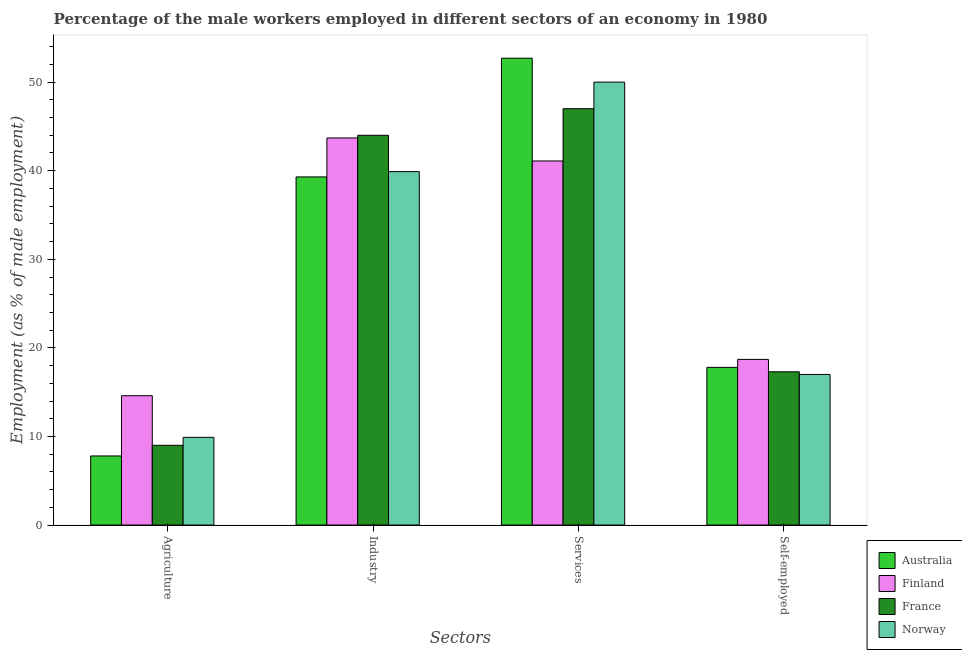How many different coloured bars are there?
Offer a terse response. 4. Are the number of bars per tick equal to the number of legend labels?
Provide a short and direct response. Yes. Are the number of bars on each tick of the X-axis equal?
Keep it short and to the point. Yes. How many bars are there on the 1st tick from the left?
Give a very brief answer. 4. How many bars are there on the 4th tick from the right?
Ensure brevity in your answer.  4. What is the label of the 3rd group of bars from the left?
Your answer should be compact. Services. What is the percentage of male workers in industry in Finland?
Offer a terse response. 43.7. Across all countries, what is the maximum percentage of male workers in industry?
Provide a short and direct response. 44. In which country was the percentage of male workers in agriculture minimum?
Offer a terse response. Australia. What is the total percentage of male workers in agriculture in the graph?
Keep it short and to the point. 41.3. What is the difference between the percentage of male workers in industry in France and that in Norway?
Offer a very short reply. 4.1. What is the difference between the percentage of male workers in industry in Australia and the percentage of self employed male workers in Finland?
Your response must be concise. 20.6. What is the average percentage of male workers in agriculture per country?
Ensure brevity in your answer.  10.33. What is the difference between the percentage of male workers in industry and percentage of male workers in services in France?
Your answer should be compact. -3. What is the ratio of the percentage of self employed male workers in Australia to that in Norway?
Ensure brevity in your answer.  1.05. Is the difference between the percentage of male workers in industry in Finland and Australia greater than the difference between the percentage of male workers in agriculture in Finland and Australia?
Your answer should be compact. No. What is the difference between the highest and the second highest percentage of male workers in industry?
Your answer should be compact. 0.3. What is the difference between the highest and the lowest percentage of male workers in agriculture?
Ensure brevity in your answer.  6.8. In how many countries, is the percentage of male workers in services greater than the average percentage of male workers in services taken over all countries?
Give a very brief answer. 2. Is it the case that in every country, the sum of the percentage of self employed male workers and percentage of male workers in industry is greater than the sum of percentage of male workers in agriculture and percentage of male workers in services?
Keep it short and to the point. Yes. What does the 3rd bar from the left in Self-employed represents?
Provide a short and direct response. France. What does the 2nd bar from the right in Agriculture represents?
Your response must be concise. France. Is it the case that in every country, the sum of the percentage of male workers in agriculture and percentage of male workers in industry is greater than the percentage of male workers in services?
Keep it short and to the point. No. Are all the bars in the graph horizontal?
Keep it short and to the point. No. What is the difference between two consecutive major ticks on the Y-axis?
Your answer should be very brief. 10. Are the values on the major ticks of Y-axis written in scientific E-notation?
Provide a short and direct response. No. Does the graph contain any zero values?
Provide a short and direct response. No. How are the legend labels stacked?
Keep it short and to the point. Vertical. What is the title of the graph?
Offer a very short reply. Percentage of the male workers employed in different sectors of an economy in 1980. Does "Fiji" appear as one of the legend labels in the graph?
Offer a terse response. No. What is the label or title of the X-axis?
Keep it short and to the point. Sectors. What is the label or title of the Y-axis?
Offer a terse response. Employment (as % of male employment). What is the Employment (as % of male employment) of Australia in Agriculture?
Your answer should be very brief. 7.8. What is the Employment (as % of male employment) of Finland in Agriculture?
Make the answer very short. 14.6. What is the Employment (as % of male employment) of France in Agriculture?
Ensure brevity in your answer.  9. What is the Employment (as % of male employment) in Norway in Agriculture?
Offer a very short reply. 9.9. What is the Employment (as % of male employment) in Australia in Industry?
Your answer should be very brief. 39.3. What is the Employment (as % of male employment) in Finland in Industry?
Offer a terse response. 43.7. What is the Employment (as % of male employment) in Norway in Industry?
Offer a terse response. 39.9. What is the Employment (as % of male employment) in Australia in Services?
Keep it short and to the point. 52.7. What is the Employment (as % of male employment) of Finland in Services?
Offer a very short reply. 41.1. What is the Employment (as % of male employment) in Australia in Self-employed?
Provide a succinct answer. 17.8. What is the Employment (as % of male employment) in Finland in Self-employed?
Your answer should be very brief. 18.7. What is the Employment (as % of male employment) in France in Self-employed?
Ensure brevity in your answer.  17.3. What is the Employment (as % of male employment) of Norway in Self-employed?
Make the answer very short. 17. Across all Sectors, what is the maximum Employment (as % of male employment) in Australia?
Provide a succinct answer. 52.7. Across all Sectors, what is the maximum Employment (as % of male employment) in Finland?
Your response must be concise. 43.7. Across all Sectors, what is the minimum Employment (as % of male employment) of Australia?
Offer a very short reply. 7.8. Across all Sectors, what is the minimum Employment (as % of male employment) in Finland?
Your answer should be compact. 14.6. Across all Sectors, what is the minimum Employment (as % of male employment) in Norway?
Ensure brevity in your answer.  9.9. What is the total Employment (as % of male employment) in Australia in the graph?
Your response must be concise. 117.6. What is the total Employment (as % of male employment) of Finland in the graph?
Your response must be concise. 118.1. What is the total Employment (as % of male employment) of France in the graph?
Your response must be concise. 117.3. What is the total Employment (as % of male employment) of Norway in the graph?
Give a very brief answer. 116.8. What is the difference between the Employment (as % of male employment) in Australia in Agriculture and that in Industry?
Your answer should be very brief. -31.5. What is the difference between the Employment (as % of male employment) in Finland in Agriculture and that in Industry?
Offer a very short reply. -29.1. What is the difference between the Employment (as % of male employment) in France in Agriculture and that in Industry?
Provide a succinct answer. -35. What is the difference between the Employment (as % of male employment) in Australia in Agriculture and that in Services?
Give a very brief answer. -44.9. What is the difference between the Employment (as % of male employment) of Finland in Agriculture and that in Services?
Your answer should be compact. -26.5. What is the difference between the Employment (as % of male employment) in France in Agriculture and that in Services?
Your answer should be very brief. -38. What is the difference between the Employment (as % of male employment) of Norway in Agriculture and that in Services?
Offer a terse response. -40.1. What is the difference between the Employment (as % of male employment) in France in Agriculture and that in Self-employed?
Keep it short and to the point. -8.3. What is the difference between the Employment (as % of male employment) of Norway in Agriculture and that in Self-employed?
Your response must be concise. -7.1. What is the difference between the Employment (as % of male employment) of Australia in Industry and that in Services?
Your answer should be very brief. -13.4. What is the difference between the Employment (as % of male employment) of Finland in Industry and that in Services?
Your response must be concise. 2.6. What is the difference between the Employment (as % of male employment) of France in Industry and that in Services?
Ensure brevity in your answer.  -3. What is the difference between the Employment (as % of male employment) of Norway in Industry and that in Services?
Ensure brevity in your answer.  -10.1. What is the difference between the Employment (as % of male employment) in Australia in Industry and that in Self-employed?
Provide a succinct answer. 21.5. What is the difference between the Employment (as % of male employment) in France in Industry and that in Self-employed?
Keep it short and to the point. 26.7. What is the difference between the Employment (as % of male employment) of Norway in Industry and that in Self-employed?
Offer a very short reply. 22.9. What is the difference between the Employment (as % of male employment) of Australia in Services and that in Self-employed?
Give a very brief answer. 34.9. What is the difference between the Employment (as % of male employment) in Finland in Services and that in Self-employed?
Ensure brevity in your answer.  22.4. What is the difference between the Employment (as % of male employment) in France in Services and that in Self-employed?
Provide a short and direct response. 29.7. What is the difference between the Employment (as % of male employment) of Norway in Services and that in Self-employed?
Offer a terse response. 33. What is the difference between the Employment (as % of male employment) in Australia in Agriculture and the Employment (as % of male employment) in Finland in Industry?
Your answer should be very brief. -35.9. What is the difference between the Employment (as % of male employment) in Australia in Agriculture and the Employment (as % of male employment) in France in Industry?
Give a very brief answer. -36.2. What is the difference between the Employment (as % of male employment) in Australia in Agriculture and the Employment (as % of male employment) in Norway in Industry?
Provide a succinct answer. -32.1. What is the difference between the Employment (as % of male employment) in Finland in Agriculture and the Employment (as % of male employment) in France in Industry?
Your answer should be very brief. -29.4. What is the difference between the Employment (as % of male employment) of Finland in Agriculture and the Employment (as % of male employment) of Norway in Industry?
Your response must be concise. -25.3. What is the difference between the Employment (as % of male employment) in France in Agriculture and the Employment (as % of male employment) in Norway in Industry?
Give a very brief answer. -30.9. What is the difference between the Employment (as % of male employment) of Australia in Agriculture and the Employment (as % of male employment) of Finland in Services?
Provide a succinct answer. -33.3. What is the difference between the Employment (as % of male employment) of Australia in Agriculture and the Employment (as % of male employment) of France in Services?
Keep it short and to the point. -39.2. What is the difference between the Employment (as % of male employment) of Australia in Agriculture and the Employment (as % of male employment) of Norway in Services?
Your response must be concise. -42.2. What is the difference between the Employment (as % of male employment) in Finland in Agriculture and the Employment (as % of male employment) in France in Services?
Ensure brevity in your answer.  -32.4. What is the difference between the Employment (as % of male employment) of Finland in Agriculture and the Employment (as % of male employment) of Norway in Services?
Offer a terse response. -35.4. What is the difference between the Employment (as % of male employment) in France in Agriculture and the Employment (as % of male employment) in Norway in Services?
Offer a terse response. -41. What is the difference between the Employment (as % of male employment) in Australia in Agriculture and the Employment (as % of male employment) in France in Self-employed?
Make the answer very short. -9.5. What is the difference between the Employment (as % of male employment) of Australia in Agriculture and the Employment (as % of male employment) of Norway in Self-employed?
Provide a succinct answer. -9.2. What is the difference between the Employment (as % of male employment) of Finland in Agriculture and the Employment (as % of male employment) of France in Self-employed?
Give a very brief answer. -2.7. What is the difference between the Employment (as % of male employment) of Finland in Agriculture and the Employment (as % of male employment) of Norway in Self-employed?
Provide a succinct answer. -2.4. What is the difference between the Employment (as % of male employment) of Finland in Industry and the Employment (as % of male employment) of Norway in Services?
Your answer should be compact. -6.3. What is the difference between the Employment (as % of male employment) of Australia in Industry and the Employment (as % of male employment) of Finland in Self-employed?
Keep it short and to the point. 20.6. What is the difference between the Employment (as % of male employment) of Australia in Industry and the Employment (as % of male employment) of France in Self-employed?
Give a very brief answer. 22. What is the difference between the Employment (as % of male employment) of Australia in Industry and the Employment (as % of male employment) of Norway in Self-employed?
Offer a terse response. 22.3. What is the difference between the Employment (as % of male employment) in Finland in Industry and the Employment (as % of male employment) in France in Self-employed?
Offer a terse response. 26.4. What is the difference between the Employment (as % of male employment) in Finland in Industry and the Employment (as % of male employment) in Norway in Self-employed?
Your answer should be very brief. 26.7. What is the difference between the Employment (as % of male employment) of France in Industry and the Employment (as % of male employment) of Norway in Self-employed?
Provide a succinct answer. 27. What is the difference between the Employment (as % of male employment) in Australia in Services and the Employment (as % of male employment) in France in Self-employed?
Offer a very short reply. 35.4. What is the difference between the Employment (as % of male employment) in Australia in Services and the Employment (as % of male employment) in Norway in Self-employed?
Your response must be concise. 35.7. What is the difference between the Employment (as % of male employment) in Finland in Services and the Employment (as % of male employment) in France in Self-employed?
Offer a very short reply. 23.8. What is the difference between the Employment (as % of male employment) of Finland in Services and the Employment (as % of male employment) of Norway in Self-employed?
Offer a very short reply. 24.1. What is the difference between the Employment (as % of male employment) in France in Services and the Employment (as % of male employment) in Norway in Self-employed?
Your answer should be very brief. 30. What is the average Employment (as % of male employment) of Australia per Sectors?
Your answer should be compact. 29.4. What is the average Employment (as % of male employment) in Finland per Sectors?
Your answer should be compact. 29.52. What is the average Employment (as % of male employment) in France per Sectors?
Your response must be concise. 29.32. What is the average Employment (as % of male employment) in Norway per Sectors?
Keep it short and to the point. 29.2. What is the difference between the Employment (as % of male employment) of Finland and Employment (as % of male employment) of France in Agriculture?
Offer a terse response. 5.6. What is the difference between the Employment (as % of male employment) of Australia and Employment (as % of male employment) of Finland in Industry?
Provide a succinct answer. -4.4. What is the difference between the Employment (as % of male employment) in Australia and Employment (as % of male employment) in Norway in Industry?
Your response must be concise. -0.6. What is the difference between the Employment (as % of male employment) in Finland and Employment (as % of male employment) in Norway in Industry?
Make the answer very short. 3.8. What is the difference between the Employment (as % of male employment) of France and Employment (as % of male employment) of Norway in Industry?
Offer a terse response. 4.1. What is the difference between the Employment (as % of male employment) in Australia and Employment (as % of male employment) in Finland in Services?
Keep it short and to the point. 11.6. What is the difference between the Employment (as % of male employment) of Australia and Employment (as % of male employment) of France in Services?
Offer a very short reply. 5.7. What is the difference between the Employment (as % of male employment) in Australia and Employment (as % of male employment) in Norway in Services?
Your answer should be very brief. 2.7. What is the difference between the Employment (as % of male employment) of Finland and Employment (as % of male employment) of Norway in Services?
Make the answer very short. -8.9. What is the difference between the Employment (as % of male employment) of France and Employment (as % of male employment) of Norway in Services?
Ensure brevity in your answer.  -3. What is the difference between the Employment (as % of male employment) of Australia and Employment (as % of male employment) of Finland in Self-employed?
Keep it short and to the point. -0.9. What is the difference between the Employment (as % of male employment) in Australia and Employment (as % of male employment) in Norway in Self-employed?
Provide a short and direct response. 0.8. What is the difference between the Employment (as % of male employment) in Finland and Employment (as % of male employment) in Norway in Self-employed?
Ensure brevity in your answer.  1.7. What is the difference between the Employment (as % of male employment) of France and Employment (as % of male employment) of Norway in Self-employed?
Ensure brevity in your answer.  0.3. What is the ratio of the Employment (as % of male employment) in Australia in Agriculture to that in Industry?
Ensure brevity in your answer.  0.2. What is the ratio of the Employment (as % of male employment) of Finland in Agriculture to that in Industry?
Your answer should be compact. 0.33. What is the ratio of the Employment (as % of male employment) of France in Agriculture to that in Industry?
Keep it short and to the point. 0.2. What is the ratio of the Employment (as % of male employment) of Norway in Agriculture to that in Industry?
Make the answer very short. 0.25. What is the ratio of the Employment (as % of male employment) in Australia in Agriculture to that in Services?
Your response must be concise. 0.15. What is the ratio of the Employment (as % of male employment) of Finland in Agriculture to that in Services?
Give a very brief answer. 0.36. What is the ratio of the Employment (as % of male employment) in France in Agriculture to that in Services?
Keep it short and to the point. 0.19. What is the ratio of the Employment (as % of male employment) of Norway in Agriculture to that in Services?
Provide a short and direct response. 0.2. What is the ratio of the Employment (as % of male employment) of Australia in Agriculture to that in Self-employed?
Offer a very short reply. 0.44. What is the ratio of the Employment (as % of male employment) of Finland in Agriculture to that in Self-employed?
Provide a succinct answer. 0.78. What is the ratio of the Employment (as % of male employment) in France in Agriculture to that in Self-employed?
Your response must be concise. 0.52. What is the ratio of the Employment (as % of male employment) in Norway in Agriculture to that in Self-employed?
Provide a short and direct response. 0.58. What is the ratio of the Employment (as % of male employment) in Australia in Industry to that in Services?
Your answer should be very brief. 0.75. What is the ratio of the Employment (as % of male employment) of Finland in Industry to that in Services?
Ensure brevity in your answer.  1.06. What is the ratio of the Employment (as % of male employment) of France in Industry to that in Services?
Offer a terse response. 0.94. What is the ratio of the Employment (as % of male employment) of Norway in Industry to that in Services?
Your answer should be very brief. 0.8. What is the ratio of the Employment (as % of male employment) of Australia in Industry to that in Self-employed?
Give a very brief answer. 2.21. What is the ratio of the Employment (as % of male employment) of Finland in Industry to that in Self-employed?
Your answer should be very brief. 2.34. What is the ratio of the Employment (as % of male employment) in France in Industry to that in Self-employed?
Make the answer very short. 2.54. What is the ratio of the Employment (as % of male employment) in Norway in Industry to that in Self-employed?
Offer a terse response. 2.35. What is the ratio of the Employment (as % of male employment) in Australia in Services to that in Self-employed?
Give a very brief answer. 2.96. What is the ratio of the Employment (as % of male employment) of Finland in Services to that in Self-employed?
Offer a terse response. 2.2. What is the ratio of the Employment (as % of male employment) of France in Services to that in Self-employed?
Your answer should be compact. 2.72. What is the ratio of the Employment (as % of male employment) in Norway in Services to that in Self-employed?
Keep it short and to the point. 2.94. What is the difference between the highest and the second highest Employment (as % of male employment) of France?
Offer a terse response. 3. What is the difference between the highest and the second highest Employment (as % of male employment) of Norway?
Your answer should be compact. 10.1. What is the difference between the highest and the lowest Employment (as % of male employment) of Australia?
Keep it short and to the point. 44.9. What is the difference between the highest and the lowest Employment (as % of male employment) of Finland?
Ensure brevity in your answer.  29.1. What is the difference between the highest and the lowest Employment (as % of male employment) of Norway?
Provide a short and direct response. 40.1. 